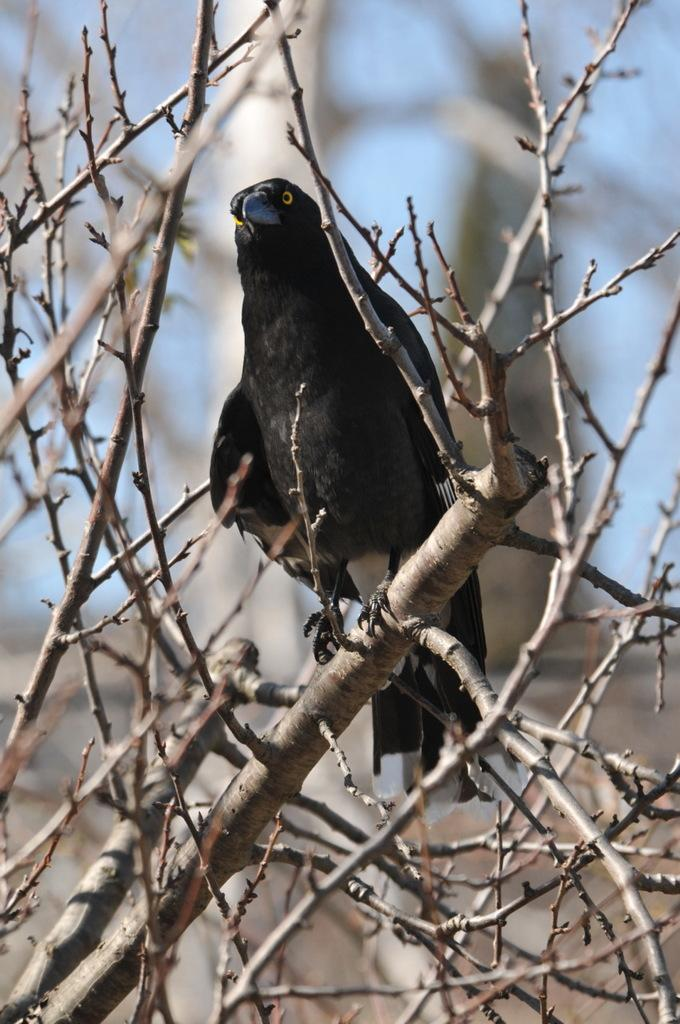What type of animal can be seen in the image? There is a bird in the image. Where is the bird located in the image? The bird is standing on a branch. What is the branch connected to? The branch is from a tree. How is the tree positioned in the image? The tree is in the center of the image. Can you describe the background of the image? The background of the image is blurry. What type of band is playing in the background of the image? There is no band present in the image; it only features a bird on a branch. 